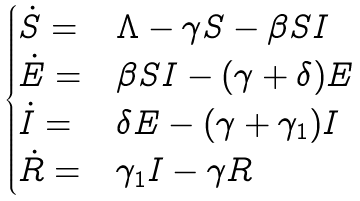Convert formula to latex. <formula><loc_0><loc_0><loc_500><loc_500>\begin{cases} \dot { S } = & \Lambda - \gamma S - \beta S I \\ \dot { E } = & \beta S I - ( \gamma + \delta ) E \\ \dot { I } = & \delta E - ( \gamma + \gamma _ { 1 } ) I \\ \dot { R } = & \gamma _ { 1 } I - \gamma R \end{cases}</formula> 